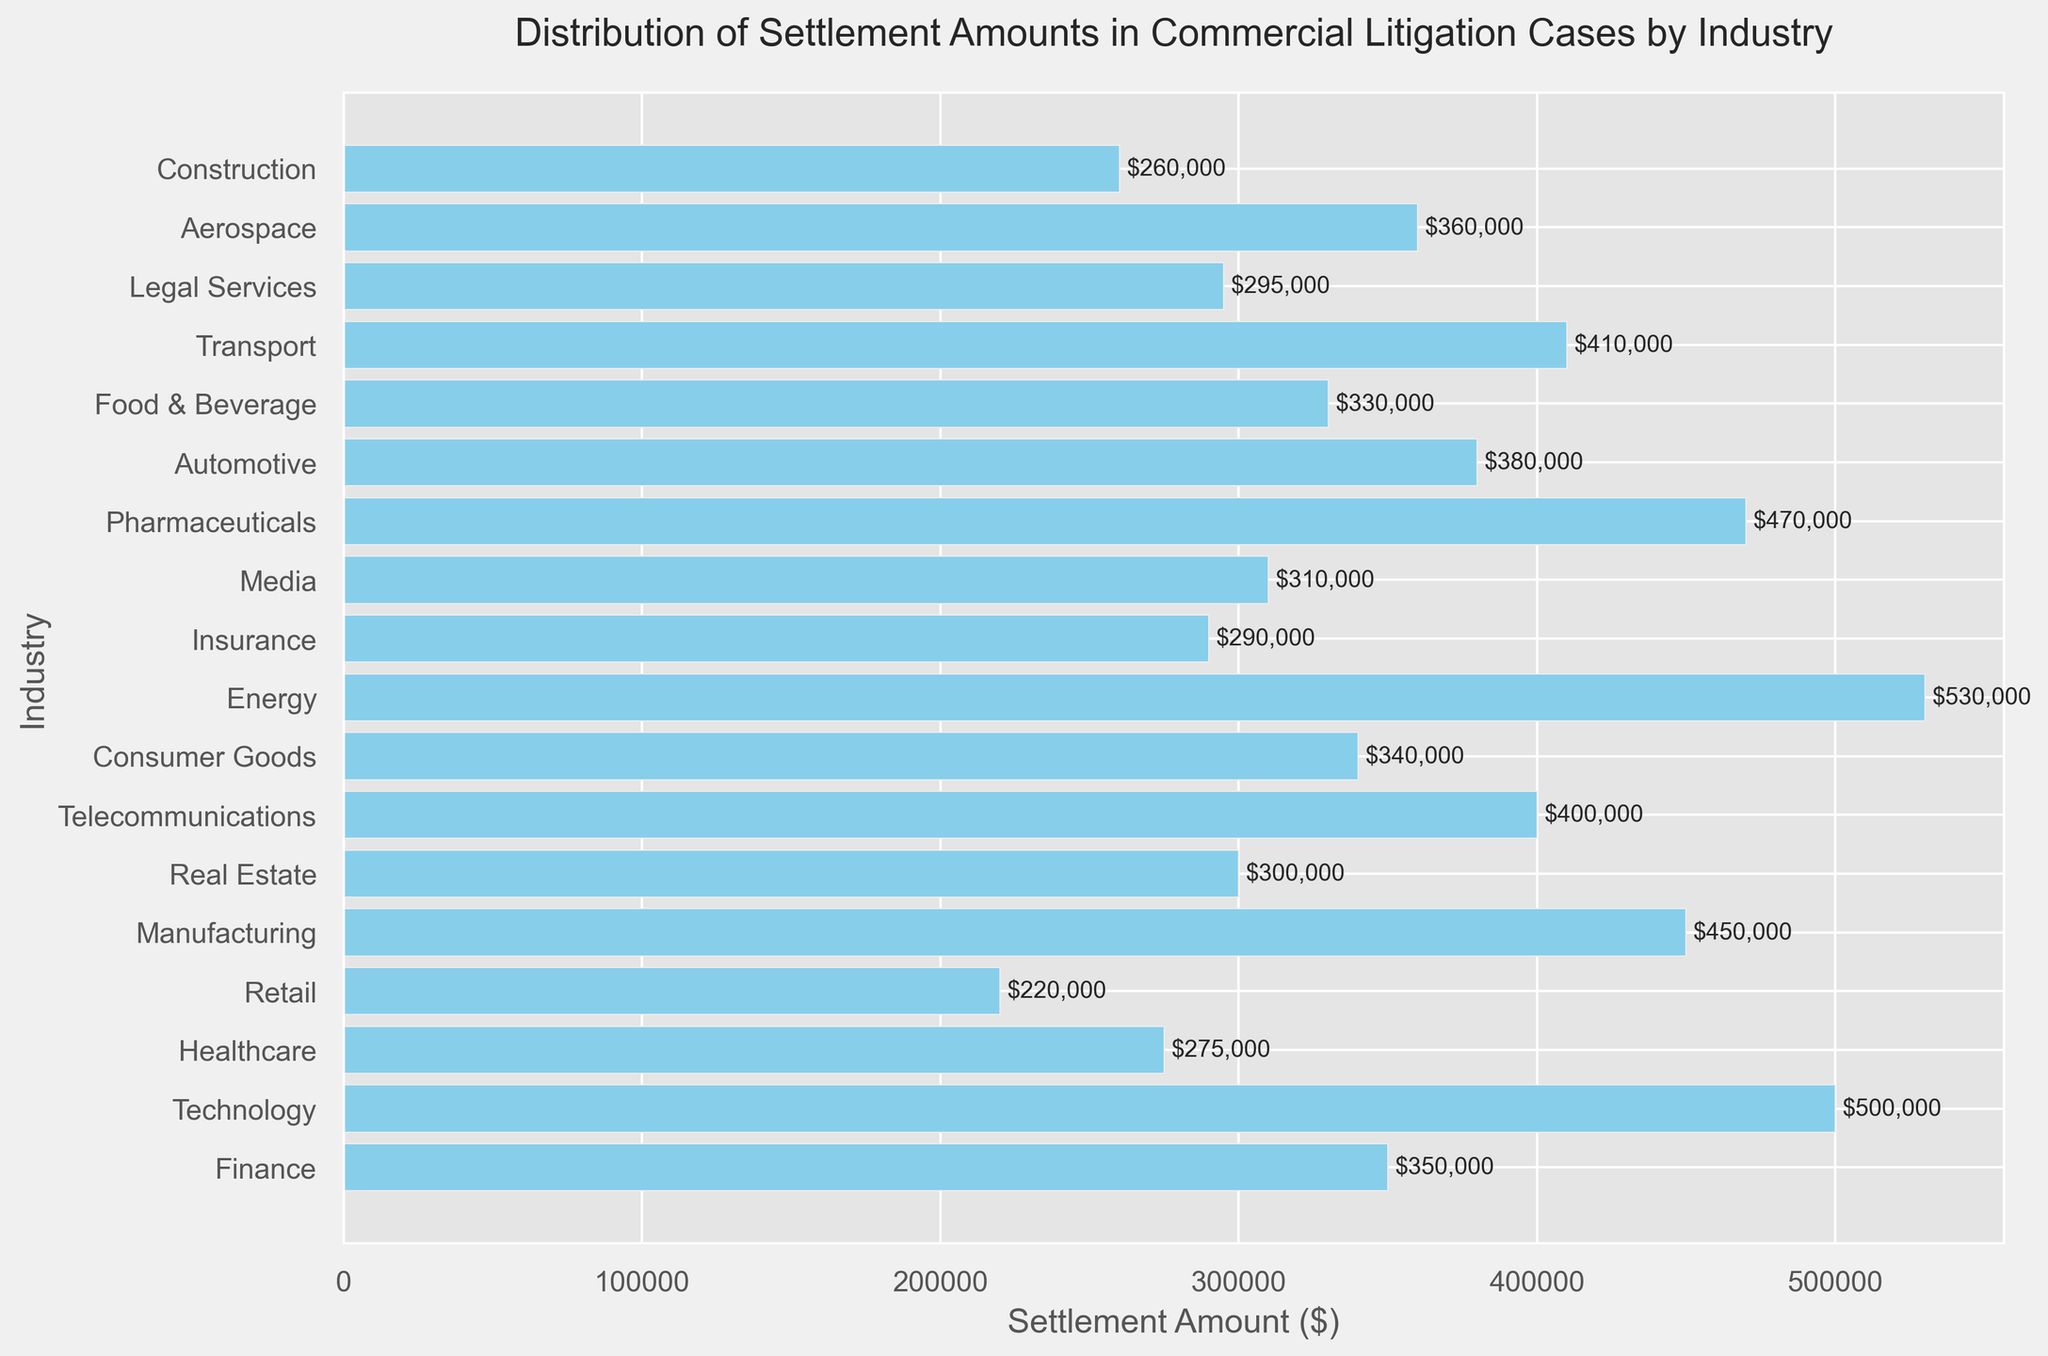Which industry has the highest settlement amount? The industry with the highest bar in the bar chart corresponds to the highest settlement amount. According to the figure, the Energy industry has the highest bar.
Answer: Energy Which industry has the lowest settlement amount? The industry with the lowest bar in the bar chart corresponds to the lowest settlement amount. According to the figure, the Retail industry has the lowest bar.
Answer: Retail What is the difference in settlement amounts between the Technology and Healthcare industries? Look at the bars for Technology and Healthcare industries and note their respective settlement amounts (500,000 and 275,000). Subtract the Healthcare amount from the Technology amount: 500,000 - 275,000 = 225,000.
Answer: 225,000 What is the average settlement amount across all industries? Add all the settlement amounts and divide by the number of industries. (350000 + 500000 + 275000 + 220000 + 450000 + 300000 + 400000 + 340000 + 530000 + 290000 + 310000 + 470000 + 380000 + 330000 + 410000 + 295000 + 360000 + 260000) / 18 = 364,444.44
Answer: 364,444.44 Which two industries have settlement amounts closest to 300,000? Identify the bars that are around 300,000. The Real Estate industry and the Legal Services industry are closest to 300,000 with amounts of 300,000 and 295,000, respectively.
Answer: Real Estate and Legal Services Among the Finance, Healthcare, and Technology industries, which one has the second highest settlement amount? Compare the settlement amounts of the Finance, Healthcare, and Technology industries (350,000, 275,000, and 500,000, respectively). The Finance industry has the second highest amount.
Answer: Finance How much more is the settlement amount for the Pharmaceutical industry compared to the Media industry? Note the settlement amounts for Pharmaceuticals and Media (470,000 and 310,000, respectively). Subtract the Media amount from the Pharmaceutical amount: 470,000 - 310,000 = 160,000.
Answer: 160,000 Which industries have settlement amounts greater than 400,000? Identify the bars with heights greater than 400,000 on the chart. These industries are Technology, Manufacturing, Energy, Pharmaceuticals, and Transport.
Answer: Technology, Manufacturing, Energy, Pharmaceuticals, and Transport What is the combined settlement amount for the Construction and Aerospace industries? Sum the settlement amounts for Construction and Aerospace industries (260,000 and 360,000 respectively). 260,000 + 360,000 = 620,000.
Answer: 620,000 What is the median settlement amount among all industries? Arrange the settlement amounts in ascending order and find the middle value(s): {220000, 260000, 275000, 290000, 295000, 300000, 310000, 330000, 340000, 350000, 360000, 380000, 400000, 410000, 450000, 470000, 500000, 530000}. Since there are 18 values, the median is the average of the 9th and 10th values: (340000 + 350000) / 2 = 345000.
Answer: 345,000 